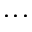Convert formula to latex. <formula><loc_0><loc_0><loc_500><loc_500>\dots</formula> 